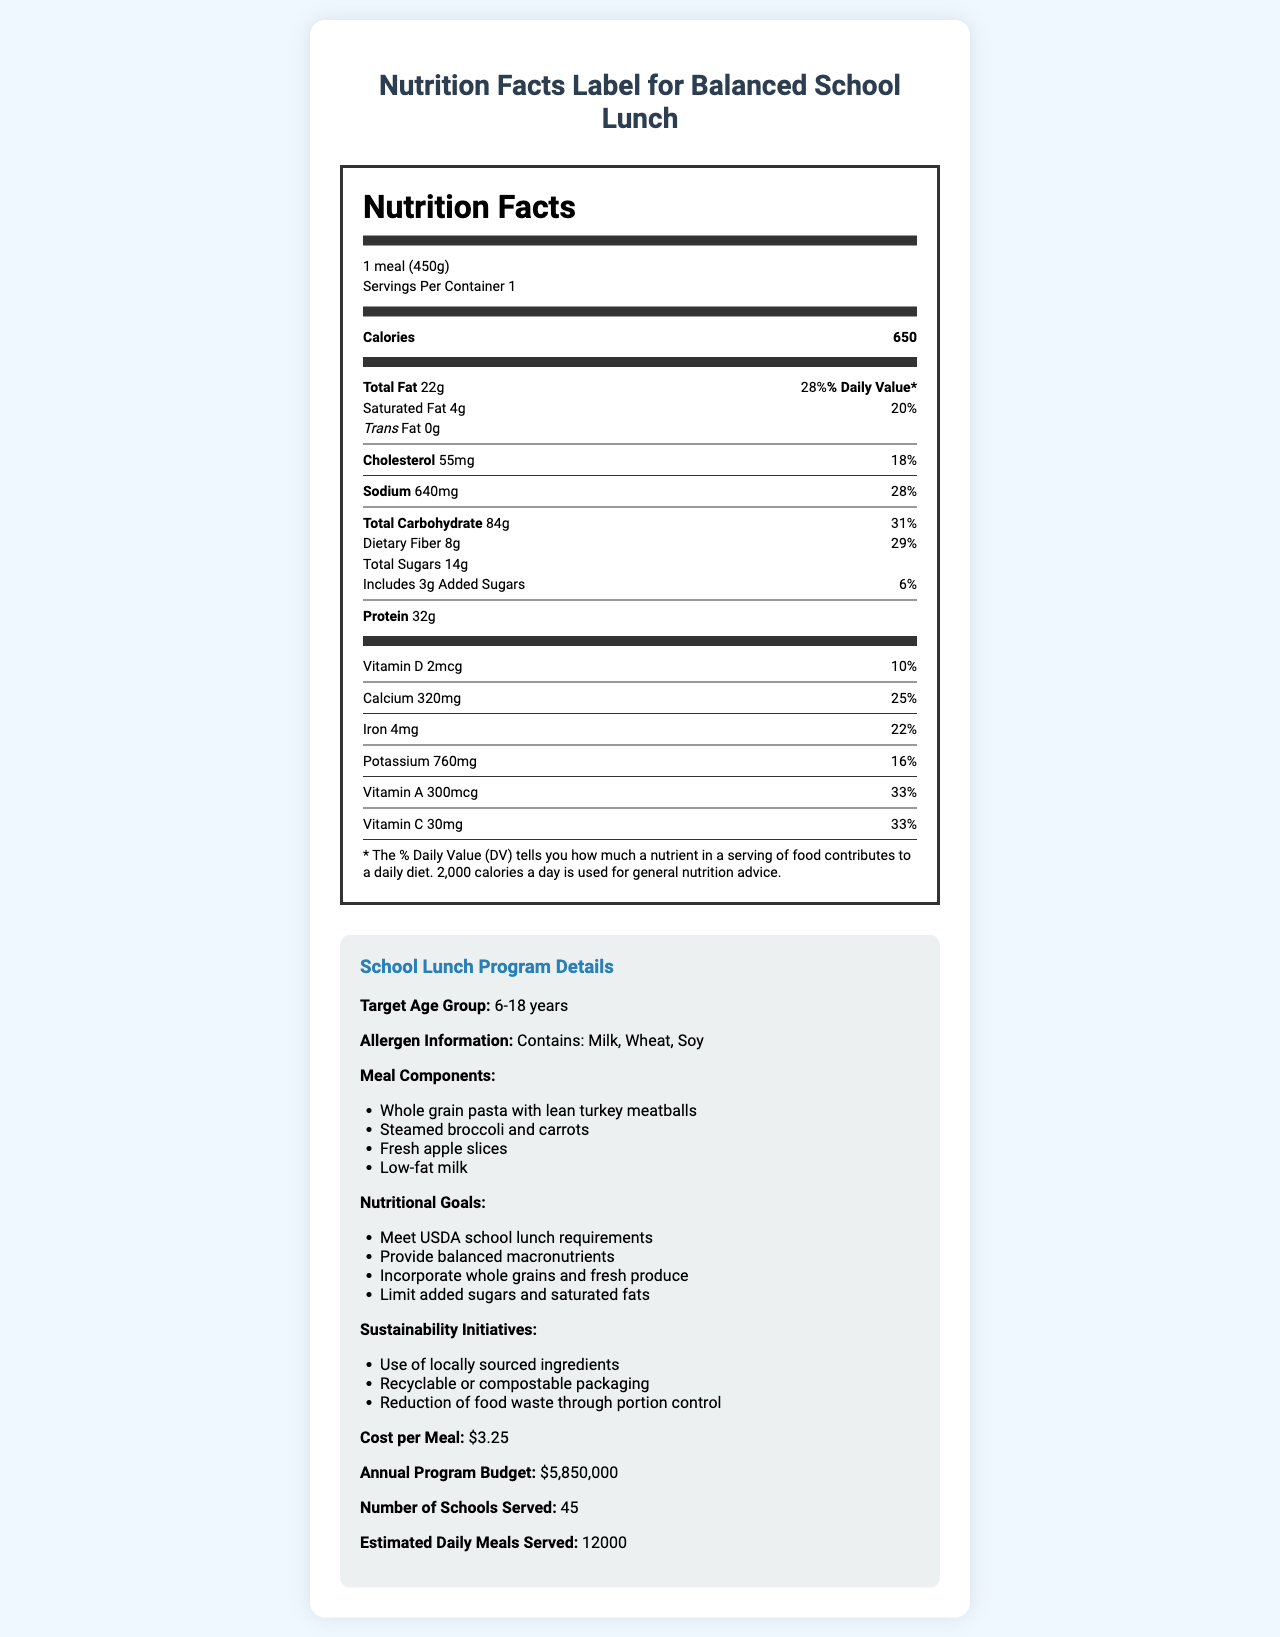what is the serving size for the Balanced School Lunch? The serving size is listed at the top of the Nutrition Facts section: "1 meal (450g)".
Answer: 1 meal (450g) how many calories are in one serving of the Balanced School Lunch? The calories per serving is given under the "Calories" section and states "Calories 650".
Answer: 650 what is the total fat percentage of the daily value in the Balanced School Lunch? The Total Fat section shows "22g" with a "% Daily Value" of "28%" right next to it.
Answer: 28% what is the amount of dietary fiber in the Balanced School Lunch? This is listed under the "Total Carbohydrate" section and specifically noted as "Dietary Fiber 8g".
Answer: 8g what vitamins does the Balanced School Lunch provide, and what are their daily values? Each of these vitamins and their corresponding daily values are listed under the vitamins section: "Vitamin D (2mcg) 10%", "Calcium (320mg) 25%", "Iron (4mg) 22%", "Potassium (760mg) 16%", "Vitamin A (300mcg) 33%", and "Vitamin C (30mg) 33%".
Answer: Vitamin D: 10%, Calcium: 25%, Iron: 22%, Potassium: 16%, Vitamin A: 33%, Vitamin C: 33% what are the main components of the meal in the Balanced School Lunch? The meal components are listed in the "Meal Components" section of the program details.
Answer: Whole grain pasta with lean turkey meatballs, Steamed broccoli and carrots, Fresh apple slices, Low-fat milk how many schools will be served by the proposed lunch program? A. 40 B. 45 C. 50 D. 60 The number of schools served by the program is listed as 45 in the program details section.
Answer: B. 45 are there any allergens in the Balanced School Lunch? The allergen information states "Contains: Milk, Wheat, Soy", indicating the presence of allergens.
Answer: Yes describe the main idea of the entire document. The explanation involves a more detailed description of the document, summarizing the key points and sections it covers.
Answer: The document is a comprehensive overview of the Balanced School Lunch program, detailing the nutritional information, meal components, program goals, sustainability initiatives, and logistics such as cost and scale of implementation. It provides both a detailed Nutrition Facts label and program specifics aimed at decision-makers evaluating the city's school lunch offerings. how much total carbohydrate is in each serving of the Balanced School Lunch? This is listed under the "Total Carbohydrate" section as "84g".
Answer: 84g what is the cost per meal for the Balanced School Lunch program? The cost per meal is provided in the program details section as "$3.25".
Answer: $3.25 what is the annual program budget for the Balanced School Lunch? The annual program budget is listed under the program details section as "$5,850,000".
Answer: $5,850,000 is the Balanced School Lunch high in sodium? (it is considered high if it provides more than 20% of the daily value) The sodium content per serving is 640mg, which constitutes 28% of the daily value, thus categorizing it as high in sodium.
Answer: Yes what specific initiatives are included in the sustainability effort of the program? These specific initiatives are listed under the "Sustainability Initiatives" section in the program details.
Answer: Use of locally sourced ingredients, Recyclable or compostable packaging, Reduction of food waste through portion control how many daily meals does the program estimate to serve? The estimated daily meals served is given as 12,000 in the program details section.
Answer: 12,000 how much total sugar is in one serving, including added sugars? Under the sugar section, it states "Total Sugars 14g" and "Includes 3g Added Sugars".
Answer: 14g total sugars, 3g added sugars does the Balanced School Lunch meet the dietary needs for children aged 6-18 years? The target age group is mentioned, but there is no direct evidence about whether it meets all dietary needs specific to that range based on the Nutrition Facts alone.
Answer: Cannot be determined which ingredient in the meal is a potential allergen? A. Whole grain pasta B. Lean turkey meatballs C. Fresh apple slices D. Low-fat milk The allergen information indicates "Milk" as a potential allergen, which is an ingredient in the "Low-fat milk".
Answer: D. Low-fat milk what is the purpose of including locally sourced ingredients in the sustainability initiatives? The document lists the use of locally sourced ingredients under sustainability initiatives, but it does not specify the exact purpose behind this choice.
Answer: Not enough information 